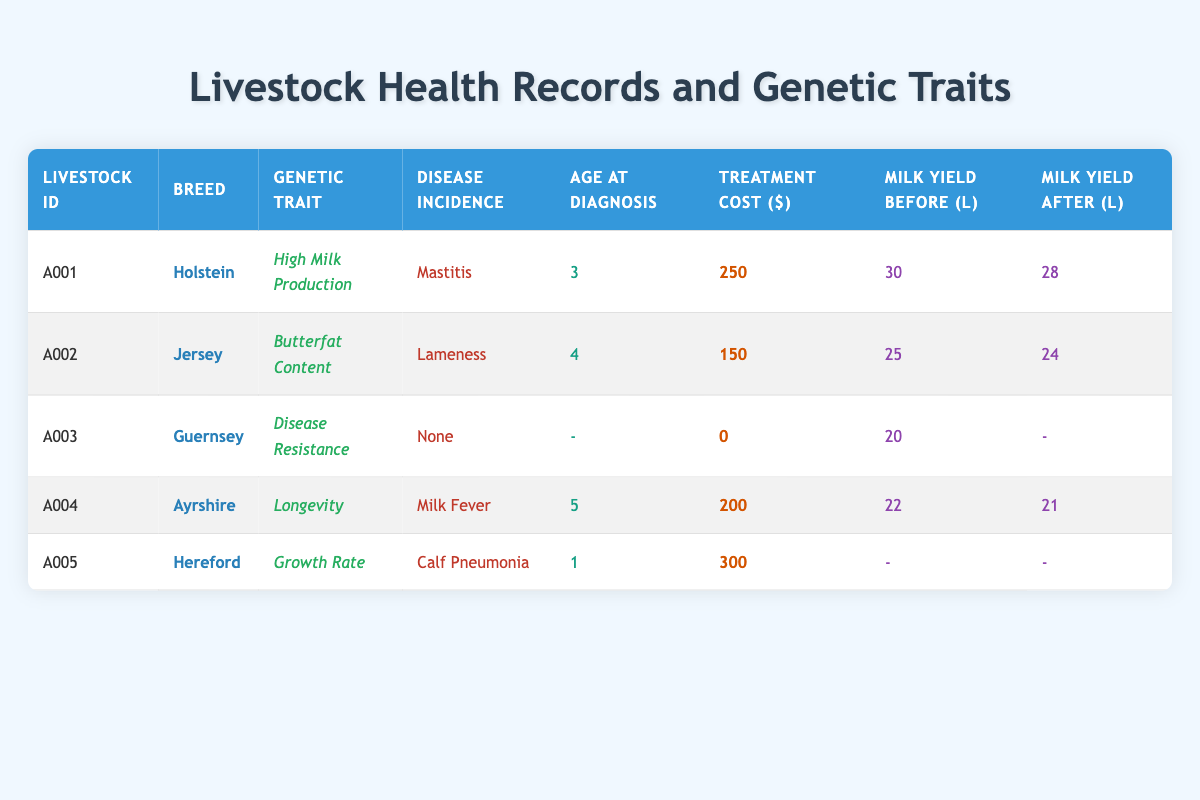What is the treatment cost for the Holstein with high milk production? The table shows that for the Holstein (LivestockID A001), the treatment cost is listed in the "Treatment Cost ($)" column, which is 250.
Answer: 250 What is the average age at diagnosis for the livestock that experienced disease incidents? The ages at diagnosis for the affected livestock are 3, 4, 5, and 1. Adding these ages gives (3 + 4 + 5 + 1) = 13. There are four livestock with disease incidents, so the average age at diagnosis is 13 / 4 = 3.25.
Answer: 3.25 Did the Guernsey livestock encounter any diseases? The table indicates that the Guernsey (LivestockID A003) has "None" in the "Disease Incidence" column, which confirms that it did not encounter any diseases.
Answer: Yes Which breed had the highest milk yield before diagnosis, and what was the amount? Looking through the "Milk Yield Before (L)" column, the largest value is 30 liters, associated with the Holstein (LivestockID A001). Thus, the Holstein had the highest milk yield before diagnosis.
Answer: Holstein, 30 liters What was the decrease in milk yield after treatment for the Ayrshire? The milk yield before treatment for the Ayrshire (LivestockID A004) was 22 liters, and after treatment, it was 21 liters. The decrease can be calculated as 22 - 21 = 1 liter.
Answer: 1 liter Which livestock had the highest treatment cost, and what disease did it encounter? Upon checking the "Treatment Cost ($)" column, the Hereford (LivestockID A005) has the highest treatment cost at 300, and it encountered "Calf Pneumonia," as indicated in the "Disease Incidence" column.
Answer: Hereford, Calf Pneumonia What was the average milk yield before diagnosis among the affected livestock? The affected livestock had milk yields before diagnosis of 30, 25, 22, and 0 (Hereford has no milk yield before diagnosis). Adding these yields gives (30 + 25 + 22) = 77, and dividing by the 3 livestock yields results in an average of 77 / 3 = 25.67.
Answer: 25.67 Did any livestock with high milk production encounter diseases? The Holstein (LivestockID A001) with the genetic trait "High Milk Production" encountered the disease "Mastitis," as per the "Disease Incidence" column.
Answer: Yes What was the status of disease incidence for the livestock with disease resistance? The table states that the Guernsey (LivestockID A003) has "None" in the "Disease Incidence" column, indicating that it did not have any diseases.
Answer: None 